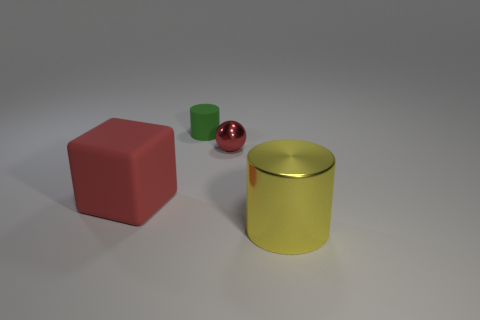Is the big yellow shiny thing the same shape as the tiny green rubber object?
Keep it short and to the point. Yes. There is a cylinder in front of the tiny thing in front of the green cylinder; what is it made of?
Your answer should be compact. Metal. Is the number of metal cylinders that are behind the large yellow thing less than the number of large metallic cylinders in front of the large matte thing?
Offer a very short reply. Yes. There is a small thing that is the same color as the large block; what is its material?
Provide a succinct answer. Metal. Is there anything else that has the same shape as the large red thing?
Keep it short and to the point. No. What is the big thing that is left of the small rubber thing made of?
Give a very brief answer. Rubber. There is a tiny green thing; are there any big yellow cylinders in front of it?
Your response must be concise. Yes. What shape is the small green matte object?
Offer a very short reply. Cylinder. What number of objects are matte things that are in front of the small red sphere or cyan matte spheres?
Offer a very short reply. 1. How many other things are there of the same color as the tiny rubber thing?
Keep it short and to the point. 0. 